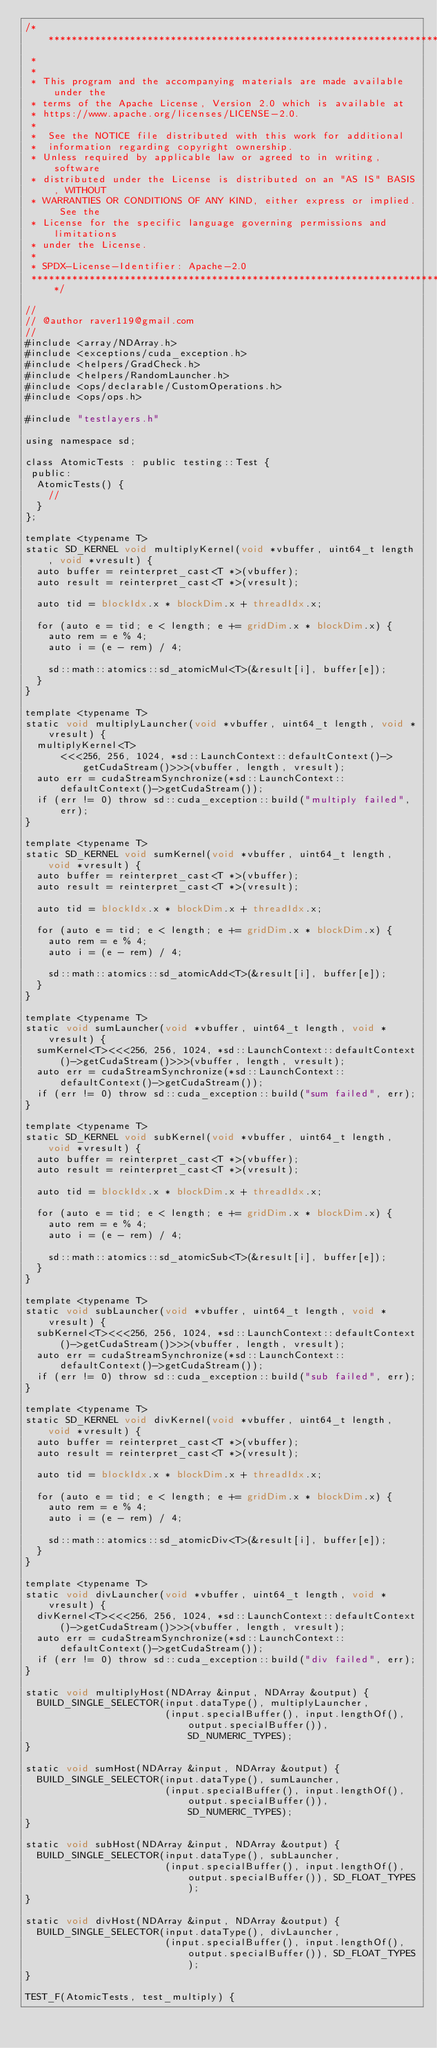Convert code to text. <code><loc_0><loc_0><loc_500><loc_500><_Cuda_>/* ******************************************************************************
 *
 *
 * This program and the accompanying materials are made available under the
 * terms of the Apache License, Version 2.0 which is available at
 * https://www.apache.org/licenses/LICENSE-2.0.
 *
 *  See the NOTICE file distributed with this work for additional
 *  information regarding copyright ownership.
 * Unless required by applicable law or agreed to in writing, software
 * distributed under the License is distributed on an "AS IS" BASIS, WITHOUT
 * WARRANTIES OR CONDITIONS OF ANY KIND, either express or implied. See the
 * License for the specific language governing permissions and limitations
 * under the License.
 *
 * SPDX-License-Identifier: Apache-2.0
 ******************************************************************************/

//
// @author raver119@gmail.com
//
#include <array/NDArray.h>
#include <exceptions/cuda_exception.h>
#include <helpers/GradCheck.h>
#include <helpers/RandomLauncher.h>
#include <ops/declarable/CustomOperations.h>
#include <ops/ops.h>

#include "testlayers.h"

using namespace sd;

class AtomicTests : public testing::Test {
 public:
  AtomicTests() {
    //
  }
};

template <typename T>
static SD_KERNEL void multiplyKernel(void *vbuffer, uint64_t length, void *vresult) {
  auto buffer = reinterpret_cast<T *>(vbuffer);
  auto result = reinterpret_cast<T *>(vresult);

  auto tid = blockIdx.x * blockDim.x + threadIdx.x;

  for (auto e = tid; e < length; e += gridDim.x * blockDim.x) {
    auto rem = e % 4;
    auto i = (e - rem) / 4;

    sd::math::atomics::sd_atomicMul<T>(&result[i], buffer[e]);
  }
}

template <typename T>
static void multiplyLauncher(void *vbuffer, uint64_t length, void *vresult) {
  multiplyKernel<T>
      <<<256, 256, 1024, *sd::LaunchContext::defaultContext()->getCudaStream()>>>(vbuffer, length, vresult);
  auto err = cudaStreamSynchronize(*sd::LaunchContext::defaultContext()->getCudaStream());
  if (err != 0) throw sd::cuda_exception::build("multiply failed", err);
}

template <typename T>
static SD_KERNEL void sumKernel(void *vbuffer, uint64_t length, void *vresult) {
  auto buffer = reinterpret_cast<T *>(vbuffer);
  auto result = reinterpret_cast<T *>(vresult);

  auto tid = blockIdx.x * blockDim.x + threadIdx.x;

  for (auto e = tid; e < length; e += gridDim.x * blockDim.x) {
    auto rem = e % 4;
    auto i = (e - rem) / 4;

    sd::math::atomics::sd_atomicAdd<T>(&result[i], buffer[e]);
  }
}

template <typename T>
static void sumLauncher(void *vbuffer, uint64_t length, void *vresult) {
  sumKernel<T><<<256, 256, 1024, *sd::LaunchContext::defaultContext()->getCudaStream()>>>(vbuffer, length, vresult);
  auto err = cudaStreamSynchronize(*sd::LaunchContext::defaultContext()->getCudaStream());
  if (err != 0) throw sd::cuda_exception::build("sum failed", err);
}

template <typename T>
static SD_KERNEL void subKernel(void *vbuffer, uint64_t length, void *vresult) {
  auto buffer = reinterpret_cast<T *>(vbuffer);
  auto result = reinterpret_cast<T *>(vresult);

  auto tid = blockIdx.x * blockDim.x + threadIdx.x;

  for (auto e = tid; e < length; e += gridDim.x * blockDim.x) {
    auto rem = e % 4;
    auto i = (e - rem) / 4;

    sd::math::atomics::sd_atomicSub<T>(&result[i], buffer[e]);
  }
}

template <typename T>
static void subLauncher(void *vbuffer, uint64_t length, void *vresult) {
  subKernel<T><<<256, 256, 1024, *sd::LaunchContext::defaultContext()->getCudaStream()>>>(vbuffer, length, vresult);
  auto err = cudaStreamSynchronize(*sd::LaunchContext::defaultContext()->getCudaStream());
  if (err != 0) throw sd::cuda_exception::build("sub failed", err);
}

template <typename T>
static SD_KERNEL void divKernel(void *vbuffer, uint64_t length, void *vresult) {
  auto buffer = reinterpret_cast<T *>(vbuffer);
  auto result = reinterpret_cast<T *>(vresult);

  auto tid = blockIdx.x * blockDim.x + threadIdx.x;

  for (auto e = tid; e < length; e += gridDim.x * blockDim.x) {
    auto rem = e % 4;
    auto i = (e - rem) / 4;

    sd::math::atomics::sd_atomicDiv<T>(&result[i], buffer[e]);
  }
}

template <typename T>
static void divLauncher(void *vbuffer, uint64_t length, void *vresult) {
  divKernel<T><<<256, 256, 1024, *sd::LaunchContext::defaultContext()->getCudaStream()>>>(vbuffer, length, vresult);
  auto err = cudaStreamSynchronize(*sd::LaunchContext::defaultContext()->getCudaStream());
  if (err != 0) throw sd::cuda_exception::build("div failed", err);
}

static void multiplyHost(NDArray &input, NDArray &output) {
  BUILD_SINGLE_SELECTOR(input.dataType(), multiplyLauncher,
                        (input.specialBuffer(), input.lengthOf(), output.specialBuffer()), SD_NUMERIC_TYPES);
}

static void sumHost(NDArray &input, NDArray &output) {
  BUILD_SINGLE_SELECTOR(input.dataType(), sumLauncher,
                        (input.specialBuffer(), input.lengthOf(), output.specialBuffer()), SD_NUMERIC_TYPES);
}

static void subHost(NDArray &input, NDArray &output) {
  BUILD_SINGLE_SELECTOR(input.dataType(), subLauncher,
                        (input.specialBuffer(), input.lengthOf(), output.specialBuffer()), SD_FLOAT_TYPES);
}

static void divHost(NDArray &input, NDArray &output) {
  BUILD_SINGLE_SELECTOR(input.dataType(), divLauncher,
                        (input.specialBuffer(), input.lengthOf(), output.specialBuffer()), SD_FLOAT_TYPES);
}

TEST_F(AtomicTests, test_multiply) {</code> 